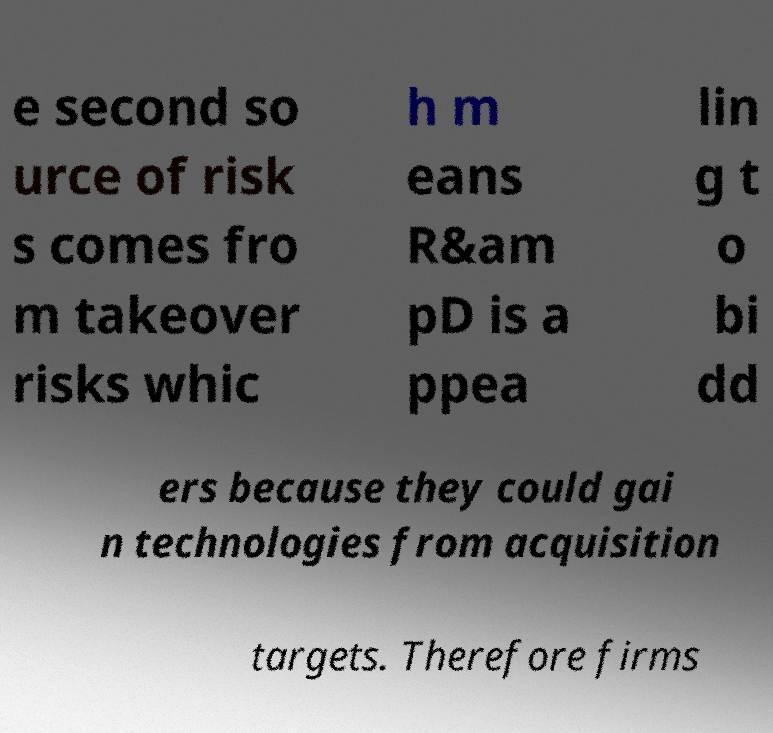I need the written content from this picture converted into text. Can you do that? e second so urce of risk s comes fro m takeover risks whic h m eans R&am pD is a ppea lin g t o bi dd ers because they could gai n technologies from acquisition targets. Therefore firms 